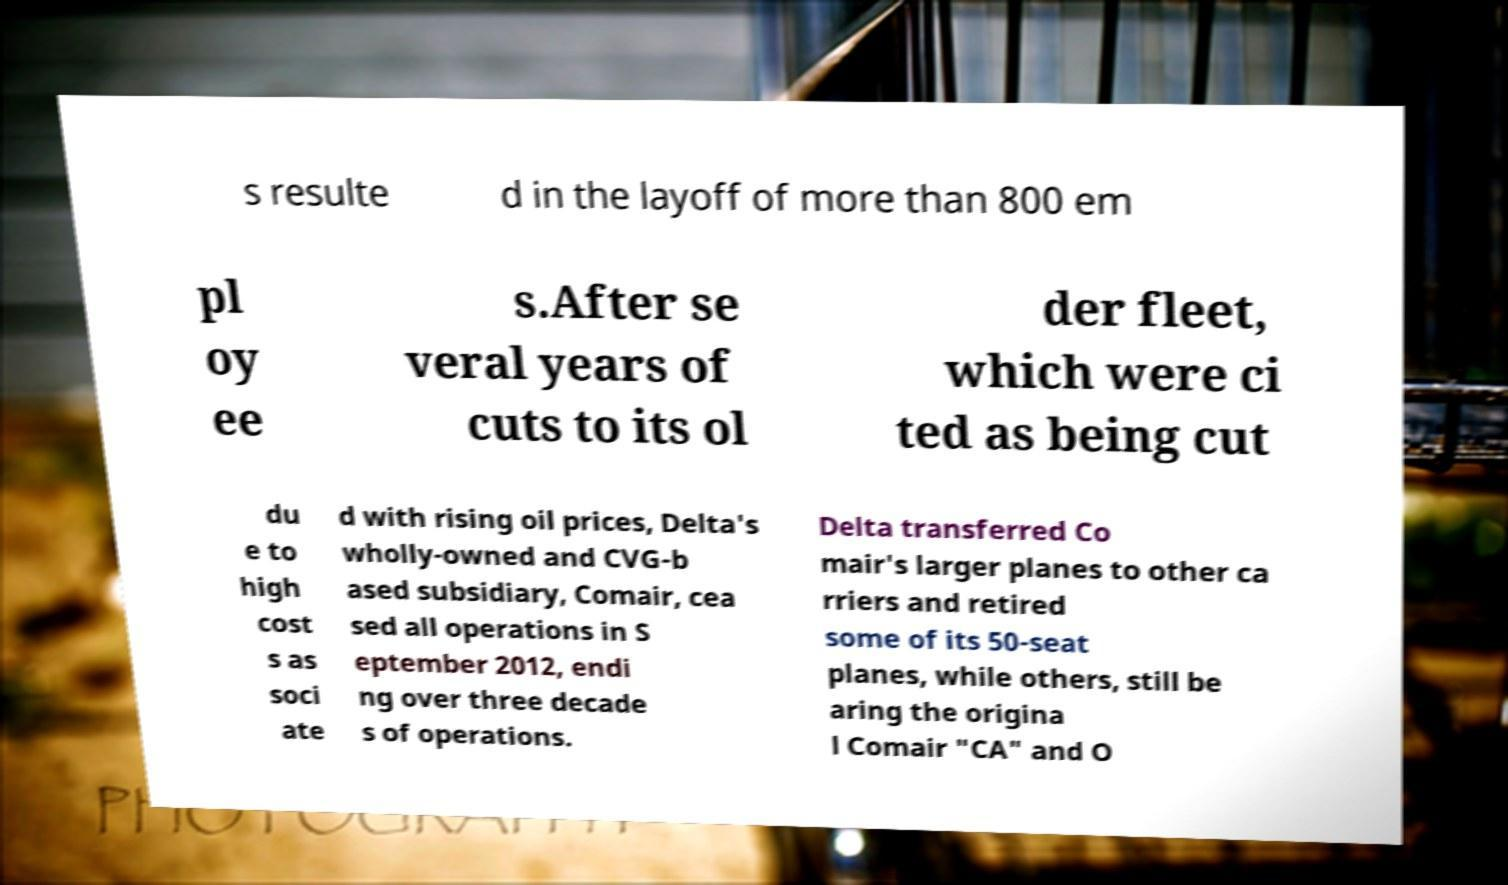What messages or text are displayed in this image? I need them in a readable, typed format. s resulte d in the layoff of more than 800 em pl oy ee s.After se veral years of cuts to its ol der fleet, which were ci ted as being cut du e to high cost s as soci ate d with rising oil prices, Delta's wholly-owned and CVG-b ased subsidiary, Comair, cea sed all operations in S eptember 2012, endi ng over three decade s of operations. Delta transferred Co mair's larger planes to other ca rriers and retired some of its 50-seat planes, while others, still be aring the origina l Comair "CA" and O 